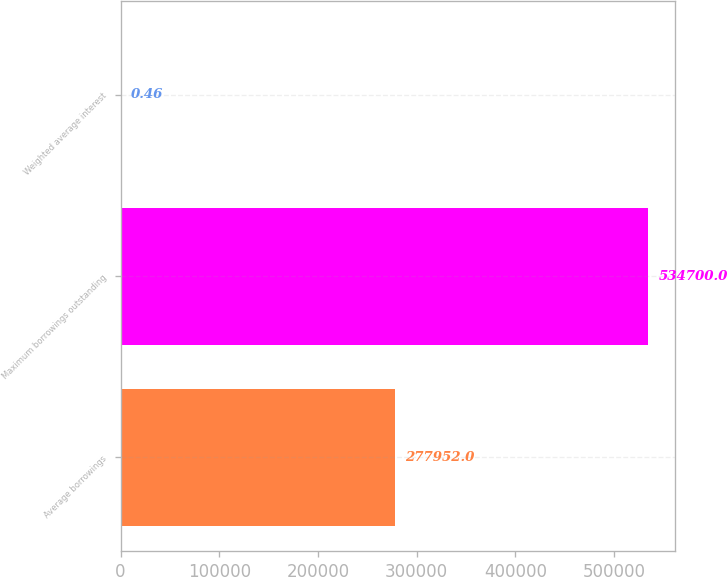Convert chart. <chart><loc_0><loc_0><loc_500><loc_500><bar_chart><fcel>Average borrowings<fcel>Maximum borrowings outstanding<fcel>Weighted average interest<nl><fcel>277952<fcel>534700<fcel>0.46<nl></chart> 